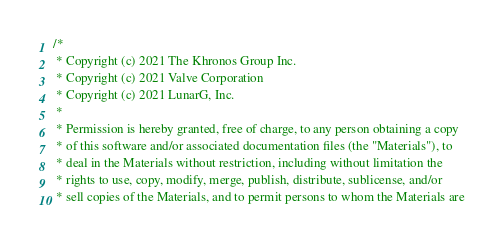<code> <loc_0><loc_0><loc_500><loc_500><_C++_>/*
 * Copyright (c) 2021 The Khronos Group Inc.
 * Copyright (c) 2021 Valve Corporation
 * Copyright (c) 2021 LunarG, Inc.
 *
 * Permission is hereby granted, free of charge, to any person obtaining a copy
 * of this software and/or associated documentation files (the "Materials"), to
 * deal in the Materials without restriction, including without limitation the
 * rights to use, copy, modify, merge, publish, distribute, sublicense, and/or
 * sell copies of the Materials, and to permit persons to whom the Materials are</code> 